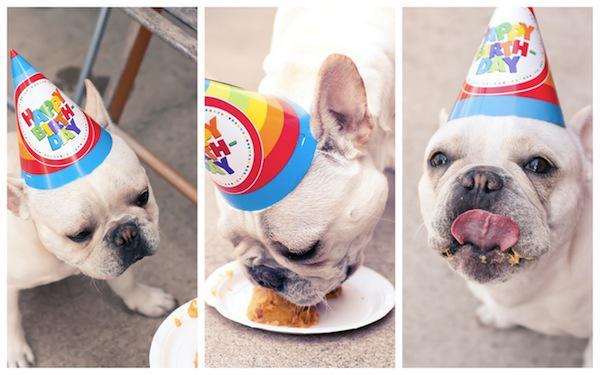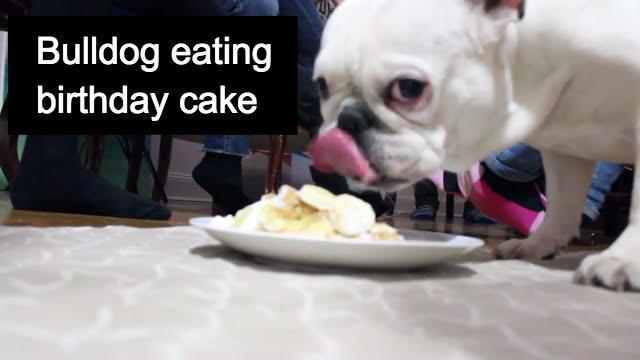The first image is the image on the left, the second image is the image on the right. Analyze the images presented: Is the assertion "A person is feeding a dog by hand." valid? Answer yes or no. No. 